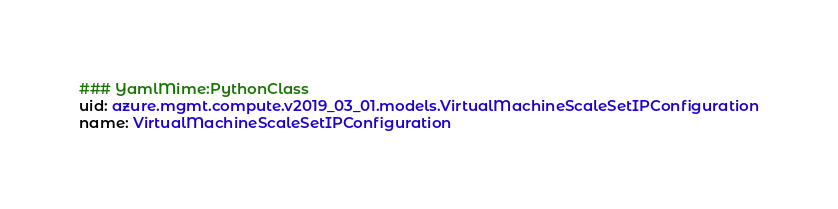<code> <loc_0><loc_0><loc_500><loc_500><_YAML_>### YamlMime:PythonClass
uid: azure.mgmt.compute.v2019_03_01.models.VirtualMachineScaleSetIPConfiguration
name: VirtualMachineScaleSetIPConfiguration</code> 